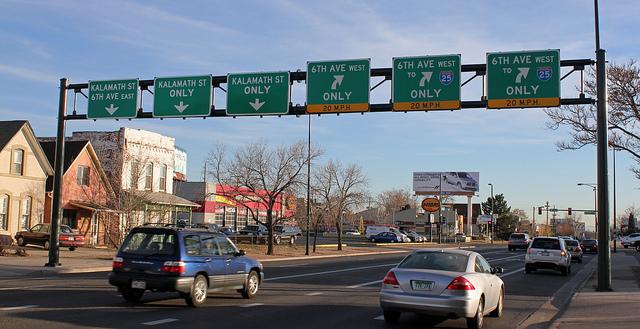What is the weather like?
Keep it brief. Sunny. How many cars are in the picture?
Concise answer only. 10. What is the speed limit for the right three lanes?
Concise answer only. 20 mph. 